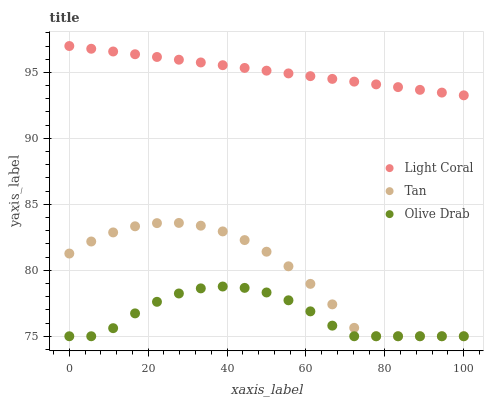Does Olive Drab have the minimum area under the curve?
Answer yes or no. Yes. Does Light Coral have the maximum area under the curve?
Answer yes or no. Yes. Does Tan have the minimum area under the curve?
Answer yes or no. No. Does Tan have the maximum area under the curve?
Answer yes or no. No. Is Light Coral the smoothest?
Answer yes or no. Yes. Is Tan the roughest?
Answer yes or no. Yes. Is Olive Drab the smoothest?
Answer yes or no. No. Is Olive Drab the roughest?
Answer yes or no. No. Does Tan have the lowest value?
Answer yes or no. Yes. Does Light Coral have the highest value?
Answer yes or no. Yes. Does Tan have the highest value?
Answer yes or no. No. Is Olive Drab less than Light Coral?
Answer yes or no. Yes. Is Light Coral greater than Tan?
Answer yes or no. Yes. Does Olive Drab intersect Tan?
Answer yes or no. Yes. Is Olive Drab less than Tan?
Answer yes or no. No. Is Olive Drab greater than Tan?
Answer yes or no. No. Does Olive Drab intersect Light Coral?
Answer yes or no. No. 